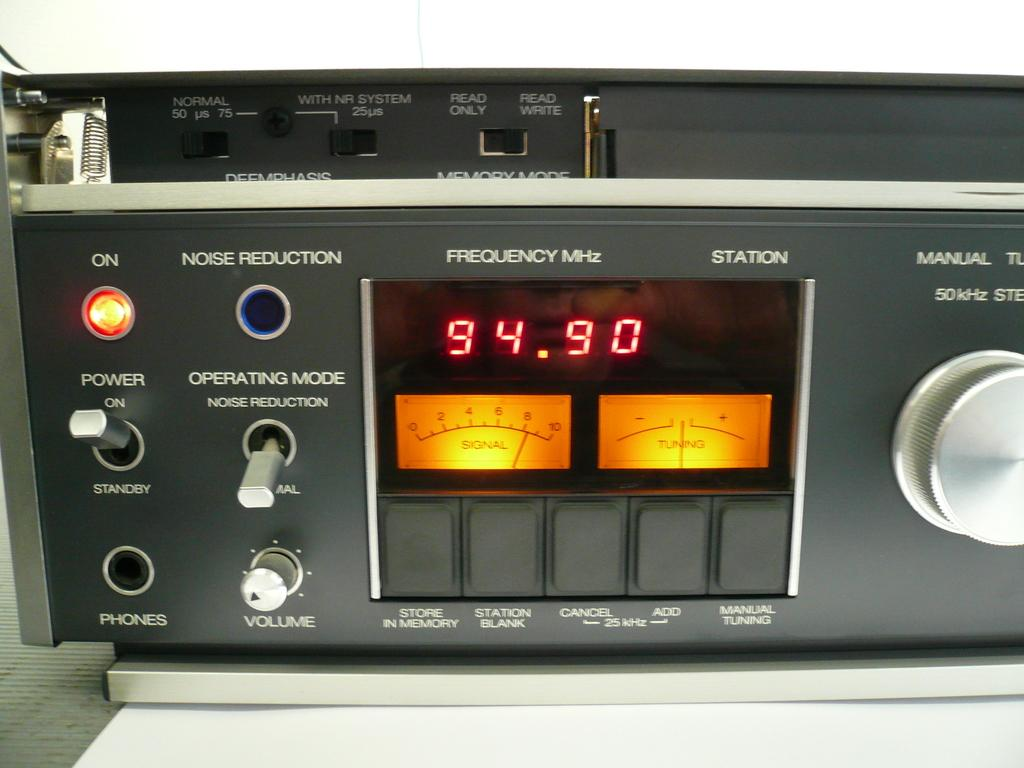<image>
Write a terse but informative summary of the picture. A piece of electronic equipment that reads a frequency of 94.90 MHz. 